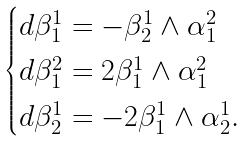Convert formula to latex. <formula><loc_0><loc_0><loc_500><loc_500>\begin{cases} d \beta ^ { 1 } _ { 1 } = - \beta ^ { 1 } _ { 2 } \wedge \alpha ^ { 2 } _ { 1 } \\ d \beta ^ { 2 } _ { 1 } = 2 \beta ^ { 1 } _ { 1 } \wedge \alpha ^ { 2 } _ { 1 } \\ d \beta ^ { 1 } _ { 2 } = - 2 \beta ^ { 1 } _ { 1 } \wedge \alpha ^ { 1 } _ { 2 } . \end{cases}</formula> 